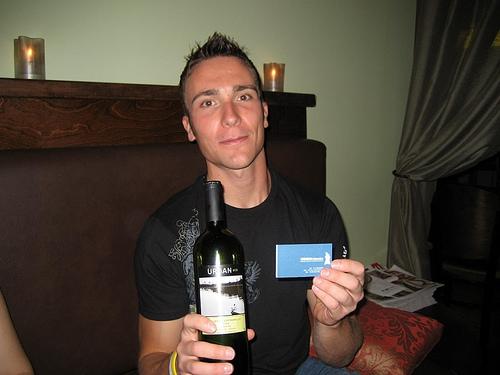Is that alcohol?
Concise answer only. Yes. Are the candle in the picture lit?
Short answer required. Yes. What is the man holding?
Concise answer only. Wine. What animal is on the bottle?
Answer briefly. Cat. 